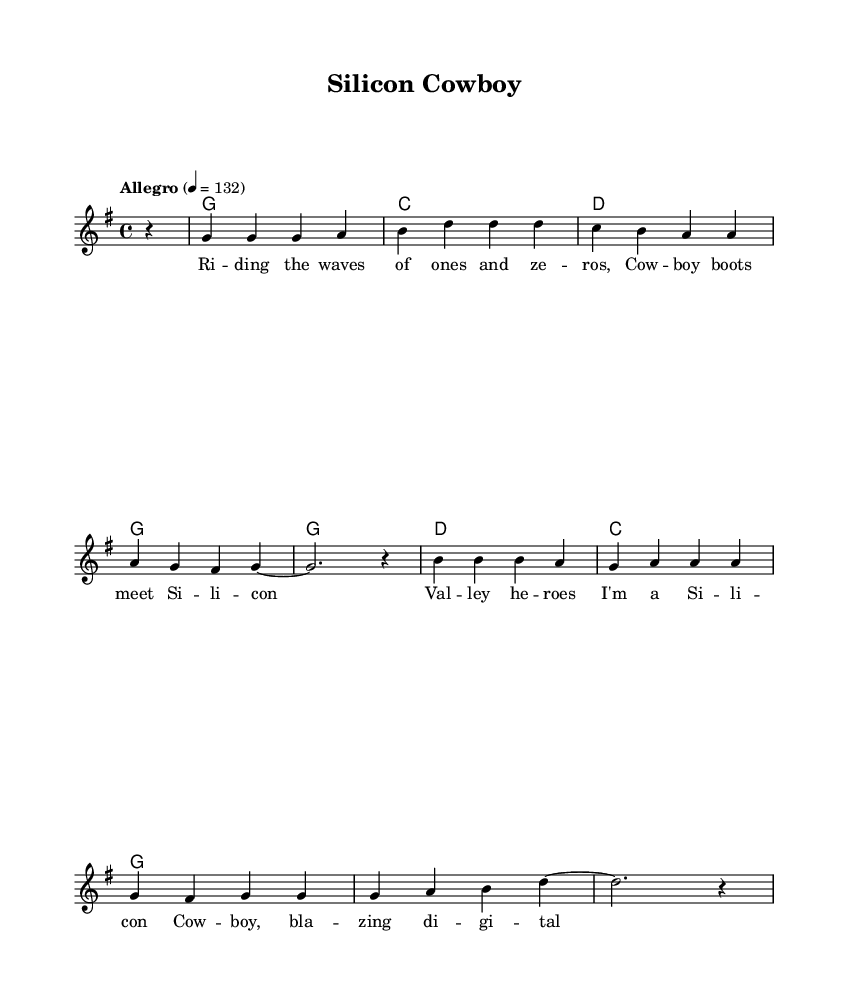What is the key signature of this music? The key signature is G major, which has one sharp (F#). This can be determined by examining the key signature section at the beginning of the sheet music.
Answer: G major What is the time signature of this music? The time signature is 4/4, which indicates that there are four beats in a measure and a quarter note gets one beat. This is found in the time signature section at the beginning of the score.
Answer: 4/4 What is the tempo marking for this piece? The tempo marking is "Allegro" at a speed of 132 beats per minute. This is indicated in the tempo section above the staff, which specifies the pace of the music.
Answer: Allegro 4 = 132 How many measures are in the chorus? There are four measures in the chorus section. By counting the number of vertical bar lines that separate the melody line, the total counts to four in the chorus part.
Answer: 4 Which chord is used most frequently in the harmonies? The chord G is used most frequently, appearing in the harmonies section at the beginning multiple times. It can be seen in the chord mode lines provided, confirming its repetition.
Answer: G What theme is celebrated in the lyrics of the song? The song celebrates technology and entrepreneurship, as indicated by references to "Silicon Valley heroes" and "innovation." The lyrics clearly depict the context of tech innovation throughout.
Answer: Technology and entrepreneurship What is the structure of the music with respect to verses and choruses? The structure consists of a verse followed by a chorus, as indicated where the verse words are provided first, followed by the chorus words. This pattern is a common structure in many songs.
Answer: Verse and chorus 